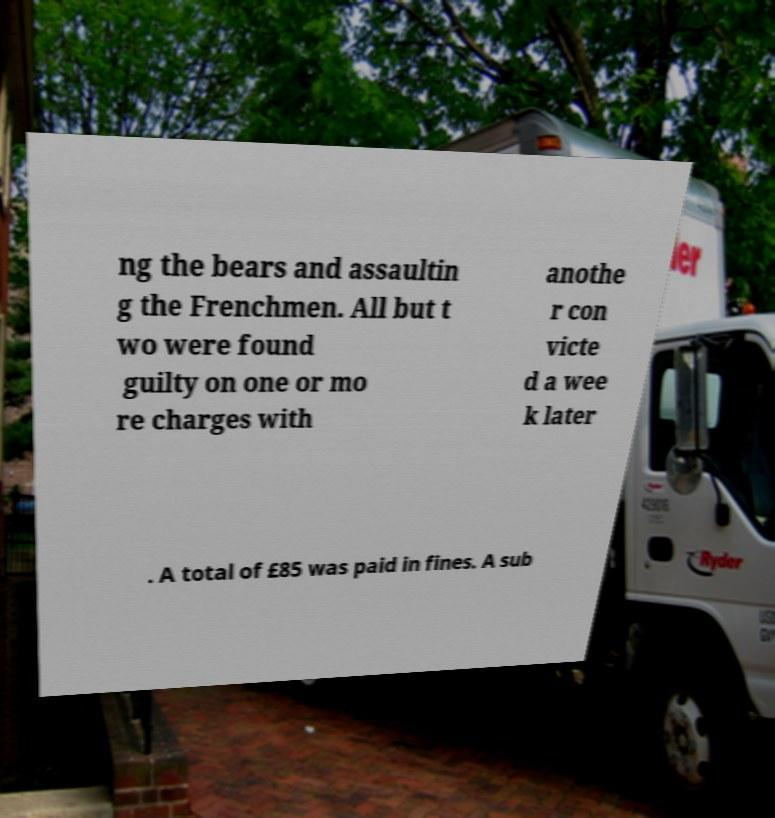For documentation purposes, I need the text within this image transcribed. Could you provide that? ng the bears and assaultin g the Frenchmen. All but t wo were found guilty on one or mo re charges with anothe r con victe d a wee k later . A total of £85 was paid in fines. A sub 